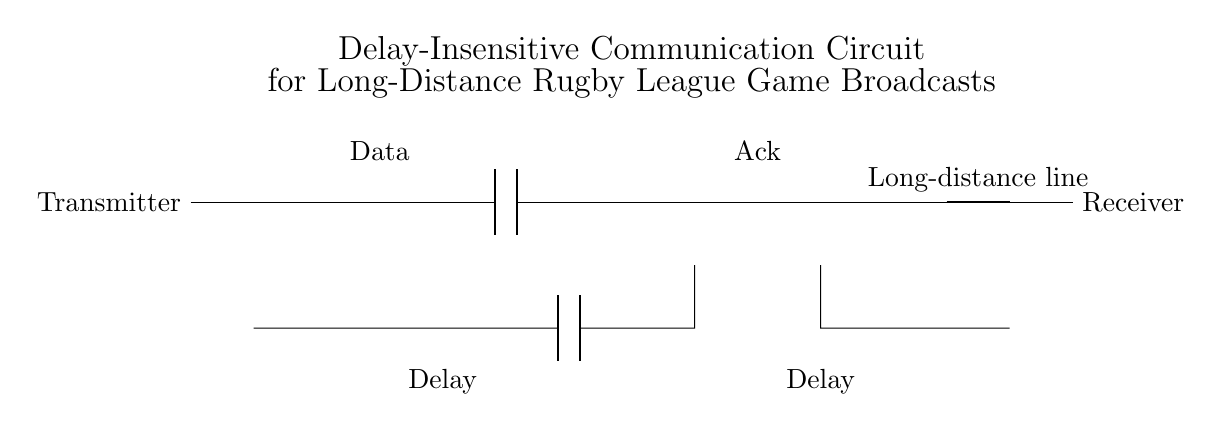What is the main purpose of the circuit? The circuit is designed for delay-insensitive communication, ensuring quick data transfer over long distances, crucial for live broadcasts.
Answer: Delay-insensitive communication What component is used to represent data transmission? The circuit shows 'Data' in the upper part, indicating where the information is sent from the transmitter.
Answer: Data How many delays are present on the transmitter side? Observing the circuit diagram, there are two distinct 'Delay' components located at the transmitter section.
Answer: Two What type of communication protocol is depicted? The circuit illustrates an asynchronous communication setup, indicated by the use of buffers and connections that allow for independent transmissions.
Answer: Asynchronous What are the roles of the ports on the transmitter side? The 'american or port' and 'american and port' manage the flow of information, with 'or' permitting alternate paths and 'and' ensuring the conjunction of signals.
Answer: Information flow management Which component is closest to the receiver side? The receiver side features the 'american and port' directly linked to the long-distance line, indicating the main entry point for received data.
Answer: American and port 